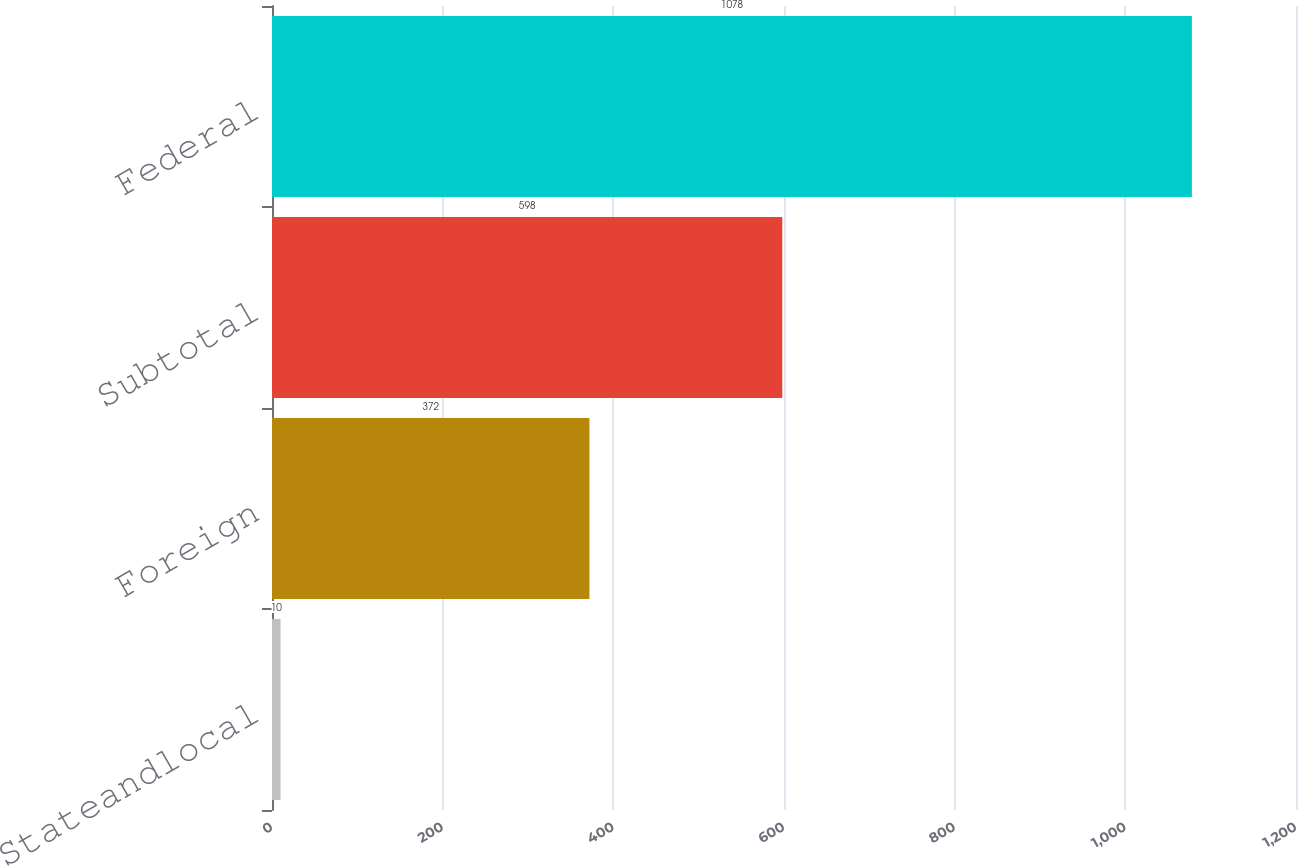Convert chart to OTSL. <chart><loc_0><loc_0><loc_500><loc_500><bar_chart><fcel>Stateandlocal<fcel>Foreign<fcel>Subtotal<fcel>Federal<nl><fcel>10<fcel>372<fcel>598<fcel>1078<nl></chart> 